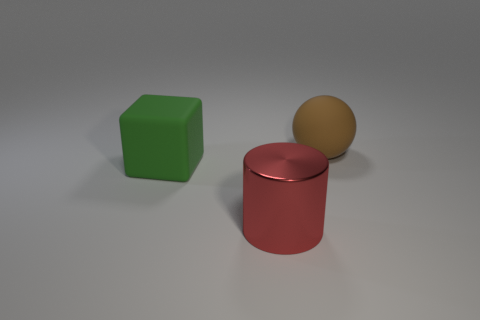There is a thing in front of the object that is to the left of the large red metal cylinder; what is its material?
Ensure brevity in your answer.  Metal. Is the number of blue rubber blocks greater than the number of big red objects?
Ensure brevity in your answer.  No. What is the material of the brown thing that is the same size as the green matte block?
Offer a terse response. Rubber. Does the large brown thing have the same material as the cylinder?
Ensure brevity in your answer.  No. What number of large cubes have the same material as the big cylinder?
Keep it short and to the point. 0. How many objects are either rubber things right of the red metal object or things that are on the right side of the matte block?
Your response must be concise. 2. Is the number of big green rubber blocks in front of the ball greater than the number of brown balls in front of the red metal cylinder?
Offer a very short reply. Yes. What color is the big rubber thing to the right of the shiny thing?
Ensure brevity in your answer.  Brown. How many gray objects are blocks or cylinders?
Offer a very short reply. 0. Are there any metal spheres that have the same size as the brown matte thing?
Offer a very short reply. No. 